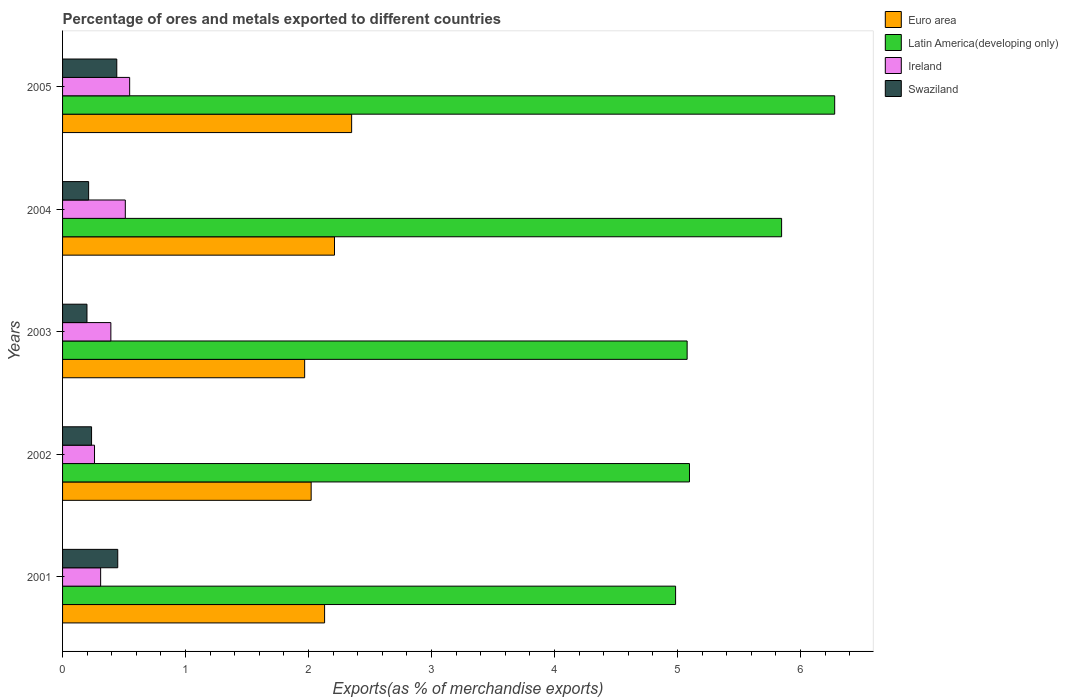How many different coloured bars are there?
Make the answer very short. 4. How many groups of bars are there?
Provide a short and direct response. 5. Are the number of bars per tick equal to the number of legend labels?
Your answer should be compact. Yes. Are the number of bars on each tick of the Y-axis equal?
Your answer should be very brief. Yes. What is the label of the 1st group of bars from the top?
Give a very brief answer. 2005. What is the percentage of exports to different countries in Swaziland in 2005?
Ensure brevity in your answer.  0.44. Across all years, what is the maximum percentage of exports to different countries in Euro area?
Provide a succinct answer. 2.35. Across all years, what is the minimum percentage of exports to different countries in Ireland?
Provide a succinct answer. 0.26. In which year was the percentage of exports to different countries in Latin America(developing only) maximum?
Your answer should be very brief. 2005. What is the total percentage of exports to different countries in Euro area in the graph?
Keep it short and to the point. 10.68. What is the difference between the percentage of exports to different countries in Swaziland in 2001 and that in 2005?
Ensure brevity in your answer.  0.01. What is the difference between the percentage of exports to different countries in Ireland in 2005 and the percentage of exports to different countries in Swaziland in 2003?
Keep it short and to the point. 0.35. What is the average percentage of exports to different countries in Euro area per year?
Give a very brief answer. 2.14. In the year 2001, what is the difference between the percentage of exports to different countries in Ireland and percentage of exports to different countries in Swaziland?
Offer a terse response. -0.14. In how many years, is the percentage of exports to different countries in Ireland greater than 2.6 %?
Offer a very short reply. 0. What is the ratio of the percentage of exports to different countries in Ireland in 2001 to that in 2003?
Your answer should be very brief. 0.79. Is the percentage of exports to different countries in Swaziland in 2004 less than that in 2005?
Offer a terse response. Yes. Is the difference between the percentage of exports to different countries in Ireland in 2001 and 2005 greater than the difference between the percentage of exports to different countries in Swaziland in 2001 and 2005?
Ensure brevity in your answer.  No. What is the difference between the highest and the second highest percentage of exports to different countries in Latin America(developing only)?
Keep it short and to the point. 0.43. What is the difference between the highest and the lowest percentage of exports to different countries in Latin America(developing only)?
Make the answer very short. 1.29. In how many years, is the percentage of exports to different countries in Euro area greater than the average percentage of exports to different countries in Euro area taken over all years?
Your answer should be compact. 2. Is it the case that in every year, the sum of the percentage of exports to different countries in Euro area and percentage of exports to different countries in Ireland is greater than the sum of percentage of exports to different countries in Latin America(developing only) and percentage of exports to different countries in Swaziland?
Offer a terse response. Yes. What does the 2nd bar from the top in 2001 represents?
Offer a terse response. Ireland. What does the 3rd bar from the bottom in 2003 represents?
Your answer should be compact. Ireland. Is it the case that in every year, the sum of the percentage of exports to different countries in Euro area and percentage of exports to different countries in Swaziland is greater than the percentage of exports to different countries in Latin America(developing only)?
Give a very brief answer. No. How many years are there in the graph?
Your response must be concise. 5. Are the values on the major ticks of X-axis written in scientific E-notation?
Ensure brevity in your answer.  No. Does the graph contain any zero values?
Your answer should be compact. No. What is the title of the graph?
Your answer should be compact. Percentage of ores and metals exported to different countries. What is the label or title of the X-axis?
Offer a very short reply. Exports(as % of merchandise exports). What is the label or title of the Y-axis?
Keep it short and to the point. Years. What is the Exports(as % of merchandise exports) of Euro area in 2001?
Your answer should be compact. 2.13. What is the Exports(as % of merchandise exports) of Latin America(developing only) in 2001?
Your answer should be compact. 4.98. What is the Exports(as % of merchandise exports) in Ireland in 2001?
Keep it short and to the point. 0.31. What is the Exports(as % of merchandise exports) in Swaziland in 2001?
Offer a very short reply. 0.45. What is the Exports(as % of merchandise exports) of Euro area in 2002?
Offer a terse response. 2.02. What is the Exports(as % of merchandise exports) of Latin America(developing only) in 2002?
Your response must be concise. 5.1. What is the Exports(as % of merchandise exports) in Ireland in 2002?
Ensure brevity in your answer.  0.26. What is the Exports(as % of merchandise exports) of Swaziland in 2002?
Ensure brevity in your answer.  0.24. What is the Exports(as % of merchandise exports) of Euro area in 2003?
Provide a succinct answer. 1.97. What is the Exports(as % of merchandise exports) of Latin America(developing only) in 2003?
Give a very brief answer. 5.08. What is the Exports(as % of merchandise exports) in Ireland in 2003?
Provide a succinct answer. 0.39. What is the Exports(as % of merchandise exports) in Swaziland in 2003?
Your answer should be compact. 0.2. What is the Exports(as % of merchandise exports) in Euro area in 2004?
Make the answer very short. 2.21. What is the Exports(as % of merchandise exports) in Latin America(developing only) in 2004?
Make the answer very short. 5.85. What is the Exports(as % of merchandise exports) in Ireland in 2004?
Provide a succinct answer. 0.51. What is the Exports(as % of merchandise exports) of Swaziland in 2004?
Provide a succinct answer. 0.21. What is the Exports(as % of merchandise exports) in Euro area in 2005?
Provide a short and direct response. 2.35. What is the Exports(as % of merchandise exports) in Latin America(developing only) in 2005?
Ensure brevity in your answer.  6.28. What is the Exports(as % of merchandise exports) in Ireland in 2005?
Ensure brevity in your answer.  0.55. What is the Exports(as % of merchandise exports) of Swaziland in 2005?
Provide a short and direct response. 0.44. Across all years, what is the maximum Exports(as % of merchandise exports) of Euro area?
Provide a short and direct response. 2.35. Across all years, what is the maximum Exports(as % of merchandise exports) in Latin America(developing only)?
Make the answer very short. 6.28. Across all years, what is the maximum Exports(as % of merchandise exports) in Ireland?
Offer a terse response. 0.55. Across all years, what is the maximum Exports(as % of merchandise exports) of Swaziland?
Offer a terse response. 0.45. Across all years, what is the minimum Exports(as % of merchandise exports) in Euro area?
Your answer should be compact. 1.97. Across all years, what is the minimum Exports(as % of merchandise exports) of Latin America(developing only)?
Make the answer very short. 4.98. Across all years, what is the minimum Exports(as % of merchandise exports) of Ireland?
Ensure brevity in your answer.  0.26. Across all years, what is the minimum Exports(as % of merchandise exports) of Swaziland?
Your answer should be very brief. 0.2. What is the total Exports(as % of merchandise exports) of Euro area in the graph?
Ensure brevity in your answer.  10.68. What is the total Exports(as % of merchandise exports) of Latin America(developing only) in the graph?
Your answer should be compact. 27.29. What is the total Exports(as % of merchandise exports) in Ireland in the graph?
Your answer should be very brief. 2.02. What is the total Exports(as % of merchandise exports) in Swaziland in the graph?
Offer a terse response. 1.54. What is the difference between the Exports(as % of merchandise exports) of Euro area in 2001 and that in 2002?
Ensure brevity in your answer.  0.11. What is the difference between the Exports(as % of merchandise exports) of Latin America(developing only) in 2001 and that in 2002?
Your response must be concise. -0.11. What is the difference between the Exports(as % of merchandise exports) of Ireland in 2001 and that in 2002?
Offer a terse response. 0.05. What is the difference between the Exports(as % of merchandise exports) in Swaziland in 2001 and that in 2002?
Make the answer very short. 0.21. What is the difference between the Exports(as % of merchandise exports) of Euro area in 2001 and that in 2003?
Keep it short and to the point. 0.16. What is the difference between the Exports(as % of merchandise exports) of Latin America(developing only) in 2001 and that in 2003?
Provide a succinct answer. -0.09. What is the difference between the Exports(as % of merchandise exports) of Ireland in 2001 and that in 2003?
Ensure brevity in your answer.  -0.08. What is the difference between the Exports(as % of merchandise exports) in Swaziland in 2001 and that in 2003?
Make the answer very short. 0.25. What is the difference between the Exports(as % of merchandise exports) in Euro area in 2001 and that in 2004?
Your response must be concise. -0.08. What is the difference between the Exports(as % of merchandise exports) in Latin America(developing only) in 2001 and that in 2004?
Your response must be concise. -0.86. What is the difference between the Exports(as % of merchandise exports) in Ireland in 2001 and that in 2004?
Offer a very short reply. -0.2. What is the difference between the Exports(as % of merchandise exports) of Swaziland in 2001 and that in 2004?
Give a very brief answer. 0.24. What is the difference between the Exports(as % of merchandise exports) in Euro area in 2001 and that in 2005?
Provide a short and direct response. -0.22. What is the difference between the Exports(as % of merchandise exports) in Latin America(developing only) in 2001 and that in 2005?
Ensure brevity in your answer.  -1.29. What is the difference between the Exports(as % of merchandise exports) of Ireland in 2001 and that in 2005?
Your answer should be compact. -0.24. What is the difference between the Exports(as % of merchandise exports) in Swaziland in 2001 and that in 2005?
Your response must be concise. 0.01. What is the difference between the Exports(as % of merchandise exports) in Euro area in 2002 and that in 2003?
Provide a succinct answer. 0.05. What is the difference between the Exports(as % of merchandise exports) of Latin America(developing only) in 2002 and that in 2003?
Your answer should be compact. 0.02. What is the difference between the Exports(as % of merchandise exports) in Ireland in 2002 and that in 2003?
Provide a succinct answer. -0.13. What is the difference between the Exports(as % of merchandise exports) of Swaziland in 2002 and that in 2003?
Offer a terse response. 0.04. What is the difference between the Exports(as % of merchandise exports) of Euro area in 2002 and that in 2004?
Your answer should be very brief. -0.19. What is the difference between the Exports(as % of merchandise exports) of Latin America(developing only) in 2002 and that in 2004?
Ensure brevity in your answer.  -0.75. What is the difference between the Exports(as % of merchandise exports) of Ireland in 2002 and that in 2004?
Your answer should be very brief. -0.25. What is the difference between the Exports(as % of merchandise exports) in Swaziland in 2002 and that in 2004?
Ensure brevity in your answer.  0.02. What is the difference between the Exports(as % of merchandise exports) in Euro area in 2002 and that in 2005?
Your answer should be very brief. -0.33. What is the difference between the Exports(as % of merchandise exports) of Latin America(developing only) in 2002 and that in 2005?
Your answer should be compact. -1.18. What is the difference between the Exports(as % of merchandise exports) in Ireland in 2002 and that in 2005?
Your response must be concise. -0.29. What is the difference between the Exports(as % of merchandise exports) in Swaziland in 2002 and that in 2005?
Offer a very short reply. -0.21. What is the difference between the Exports(as % of merchandise exports) in Euro area in 2003 and that in 2004?
Provide a succinct answer. -0.24. What is the difference between the Exports(as % of merchandise exports) in Latin America(developing only) in 2003 and that in 2004?
Give a very brief answer. -0.77. What is the difference between the Exports(as % of merchandise exports) in Ireland in 2003 and that in 2004?
Give a very brief answer. -0.12. What is the difference between the Exports(as % of merchandise exports) in Swaziland in 2003 and that in 2004?
Offer a terse response. -0.01. What is the difference between the Exports(as % of merchandise exports) in Euro area in 2003 and that in 2005?
Your answer should be very brief. -0.38. What is the difference between the Exports(as % of merchandise exports) in Latin America(developing only) in 2003 and that in 2005?
Provide a short and direct response. -1.2. What is the difference between the Exports(as % of merchandise exports) of Ireland in 2003 and that in 2005?
Your answer should be compact. -0.15. What is the difference between the Exports(as % of merchandise exports) of Swaziland in 2003 and that in 2005?
Give a very brief answer. -0.24. What is the difference between the Exports(as % of merchandise exports) of Euro area in 2004 and that in 2005?
Your answer should be very brief. -0.14. What is the difference between the Exports(as % of merchandise exports) in Latin America(developing only) in 2004 and that in 2005?
Ensure brevity in your answer.  -0.43. What is the difference between the Exports(as % of merchandise exports) in Ireland in 2004 and that in 2005?
Ensure brevity in your answer.  -0.04. What is the difference between the Exports(as % of merchandise exports) of Swaziland in 2004 and that in 2005?
Your answer should be compact. -0.23. What is the difference between the Exports(as % of merchandise exports) in Euro area in 2001 and the Exports(as % of merchandise exports) in Latin America(developing only) in 2002?
Keep it short and to the point. -2.97. What is the difference between the Exports(as % of merchandise exports) of Euro area in 2001 and the Exports(as % of merchandise exports) of Ireland in 2002?
Your response must be concise. 1.87. What is the difference between the Exports(as % of merchandise exports) of Euro area in 2001 and the Exports(as % of merchandise exports) of Swaziland in 2002?
Keep it short and to the point. 1.89. What is the difference between the Exports(as % of merchandise exports) in Latin America(developing only) in 2001 and the Exports(as % of merchandise exports) in Ireland in 2002?
Provide a succinct answer. 4.72. What is the difference between the Exports(as % of merchandise exports) in Latin America(developing only) in 2001 and the Exports(as % of merchandise exports) in Swaziland in 2002?
Your answer should be compact. 4.75. What is the difference between the Exports(as % of merchandise exports) of Ireland in 2001 and the Exports(as % of merchandise exports) of Swaziland in 2002?
Ensure brevity in your answer.  0.07. What is the difference between the Exports(as % of merchandise exports) in Euro area in 2001 and the Exports(as % of merchandise exports) in Latin America(developing only) in 2003?
Provide a short and direct response. -2.95. What is the difference between the Exports(as % of merchandise exports) of Euro area in 2001 and the Exports(as % of merchandise exports) of Ireland in 2003?
Give a very brief answer. 1.74. What is the difference between the Exports(as % of merchandise exports) in Euro area in 2001 and the Exports(as % of merchandise exports) in Swaziland in 2003?
Ensure brevity in your answer.  1.93. What is the difference between the Exports(as % of merchandise exports) in Latin America(developing only) in 2001 and the Exports(as % of merchandise exports) in Ireland in 2003?
Provide a succinct answer. 4.59. What is the difference between the Exports(as % of merchandise exports) in Latin America(developing only) in 2001 and the Exports(as % of merchandise exports) in Swaziland in 2003?
Provide a short and direct response. 4.79. What is the difference between the Exports(as % of merchandise exports) in Ireland in 2001 and the Exports(as % of merchandise exports) in Swaziland in 2003?
Your answer should be compact. 0.11. What is the difference between the Exports(as % of merchandise exports) of Euro area in 2001 and the Exports(as % of merchandise exports) of Latin America(developing only) in 2004?
Your answer should be very brief. -3.72. What is the difference between the Exports(as % of merchandise exports) of Euro area in 2001 and the Exports(as % of merchandise exports) of Ireland in 2004?
Provide a short and direct response. 1.62. What is the difference between the Exports(as % of merchandise exports) of Euro area in 2001 and the Exports(as % of merchandise exports) of Swaziland in 2004?
Your answer should be very brief. 1.92. What is the difference between the Exports(as % of merchandise exports) in Latin America(developing only) in 2001 and the Exports(as % of merchandise exports) in Ireland in 2004?
Offer a terse response. 4.47. What is the difference between the Exports(as % of merchandise exports) in Latin America(developing only) in 2001 and the Exports(as % of merchandise exports) in Swaziland in 2004?
Offer a terse response. 4.77. What is the difference between the Exports(as % of merchandise exports) of Ireland in 2001 and the Exports(as % of merchandise exports) of Swaziland in 2004?
Your response must be concise. 0.1. What is the difference between the Exports(as % of merchandise exports) in Euro area in 2001 and the Exports(as % of merchandise exports) in Latin America(developing only) in 2005?
Ensure brevity in your answer.  -4.15. What is the difference between the Exports(as % of merchandise exports) of Euro area in 2001 and the Exports(as % of merchandise exports) of Ireland in 2005?
Ensure brevity in your answer.  1.59. What is the difference between the Exports(as % of merchandise exports) of Euro area in 2001 and the Exports(as % of merchandise exports) of Swaziland in 2005?
Give a very brief answer. 1.69. What is the difference between the Exports(as % of merchandise exports) of Latin America(developing only) in 2001 and the Exports(as % of merchandise exports) of Ireland in 2005?
Offer a very short reply. 4.44. What is the difference between the Exports(as % of merchandise exports) of Latin America(developing only) in 2001 and the Exports(as % of merchandise exports) of Swaziland in 2005?
Provide a succinct answer. 4.54. What is the difference between the Exports(as % of merchandise exports) of Ireland in 2001 and the Exports(as % of merchandise exports) of Swaziland in 2005?
Provide a succinct answer. -0.13. What is the difference between the Exports(as % of merchandise exports) in Euro area in 2002 and the Exports(as % of merchandise exports) in Latin America(developing only) in 2003?
Keep it short and to the point. -3.06. What is the difference between the Exports(as % of merchandise exports) of Euro area in 2002 and the Exports(as % of merchandise exports) of Ireland in 2003?
Ensure brevity in your answer.  1.63. What is the difference between the Exports(as % of merchandise exports) of Euro area in 2002 and the Exports(as % of merchandise exports) of Swaziland in 2003?
Your answer should be compact. 1.82. What is the difference between the Exports(as % of merchandise exports) in Latin America(developing only) in 2002 and the Exports(as % of merchandise exports) in Ireland in 2003?
Keep it short and to the point. 4.71. What is the difference between the Exports(as % of merchandise exports) of Latin America(developing only) in 2002 and the Exports(as % of merchandise exports) of Swaziland in 2003?
Ensure brevity in your answer.  4.9. What is the difference between the Exports(as % of merchandise exports) in Ireland in 2002 and the Exports(as % of merchandise exports) in Swaziland in 2003?
Your answer should be compact. 0.06. What is the difference between the Exports(as % of merchandise exports) in Euro area in 2002 and the Exports(as % of merchandise exports) in Latin America(developing only) in 2004?
Offer a very short reply. -3.83. What is the difference between the Exports(as % of merchandise exports) in Euro area in 2002 and the Exports(as % of merchandise exports) in Ireland in 2004?
Keep it short and to the point. 1.51. What is the difference between the Exports(as % of merchandise exports) of Euro area in 2002 and the Exports(as % of merchandise exports) of Swaziland in 2004?
Your response must be concise. 1.81. What is the difference between the Exports(as % of merchandise exports) of Latin America(developing only) in 2002 and the Exports(as % of merchandise exports) of Ireland in 2004?
Your answer should be very brief. 4.59. What is the difference between the Exports(as % of merchandise exports) in Latin America(developing only) in 2002 and the Exports(as % of merchandise exports) in Swaziland in 2004?
Your answer should be compact. 4.89. What is the difference between the Exports(as % of merchandise exports) of Ireland in 2002 and the Exports(as % of merchandise exports) of Swaziland in 2004?
Keep it short and to the point. 0.05. What is the difference between the Exports(as % of merchandise exports) of Euro area in 2002 and the Exports(as % of merchandise exports) of Latin America(developing only) in 2005?
Offer a terse response. -4.26. What is the difference between the Exports(as % of merchandise exports) of Euro area in 2002 and the Exports(as % of merchandise exports) of Ireland in 2005?
Provide a succinct answer. 1.48. What is the difference between the Exports(as % of merchandise exports) of Euro area in 2002 and the Exports(as % of merchandise exports) of Swaziland in 2005?
Give a very brief answer. 1.58. What is the difference between the Exports(as % of merchandise exports) of Latin America(developing only) in 2002 and the Exports(as % of merchandise exports) of Ireland in 2005?
Make the answer very short. 4.55. What is the difference between the Exports(as % of merchandise exports) of Latin America(developing only) in 2002 and the Exports(as % of merchandise exports) of Swaziland in 2005?
Ensure brevity in your answer.  4.66. What is the difference between the Exports(as % of merchandise exports) in Ireland in 2002 and the Exports(as % of merchandise exports) in Swaziland in 2005?
Your answer should be very brief. -0.18. What is the difference between the Exports(as % of merchandise exports) in Euro area in 2003 and the Exports(as % of merchandise exports) in Latin America(developing only) in 2004?
Provide a short and direct response. -3.88. What is the difference between the Exports(as % of merchandise exports) in Euro area in 2003 and the Exports(as % of merchandise exports) in Ireland in 2004?
Ensure brevity in your answer.  1.46. What is the difference between the Exports(as % of merchandise exports) in Euro area in 2003 and the Exports(as % of merchandise exports) in Swaziland in 2004?
Offer a very short reply. 1.76. What is the difference between the Exports(as % of merchandise exports) in Latin America(developing only) in 2003 and the Exports(as % of merchandise exports) in Ireland in 2004?
Offer a very short reply. 4.57. What is the difference between the Exports(as % of merchandise exports) of Latin America(developing only) in 2003 and the Exports(as % of merchandise exports) of Swaziland in 2004?
Your answer should be compact. 4.87. What is the difference between the Exports(as % of merchandise exports) of Ireland in 2003 and the Exports(as % of merchandise exports) of Swaziland in 2004?
Your answer should be compact. 0.18. What is the difference between the Exports(as % of merchandise exports) of Euro area in 2003 and the Exports(as % of merchandise exports) of Latin America(developing only) in 2005?
Your answer should be very brief. -4.31. What is the difference between the Exports(as % of merchandise exports) of Euro area in 2003 and the Exports(as % of merchandise exports) of Ireland in 2005?
Offer a very short reply. 1.42. What is the difference between the Exports(as % of merchandise exports) in Euro area in 2003 and the Exports(as % of merchandise exports) in Swaziland in 2005?
Your answer should be compact. 1.53. What is the difference between the Exports(as % of merchandise exports) in Latin America(developing only) in 2003 and the Exports(as % of merchandise exports) in Ireland in 2005?
Keep it short and to the point. 4.53. What is the difference between the Exports(as % of merchandise exports) of Latin America(developing only) in 2003 and the Exports(as % of merchandise exports) of Swaziland in 2005?
Your response must be concise. 4.64. What is the difference between the Exports(as % of merchandise exports) in Ireland in 2003 and the Exports(as % of merchandise exports) in Swaziland in 2005?
Keep it short and to the point. -0.05. What is the difference between the Exports(as % of merchandise exports) in Euro area in 2004 and the Exports(as % of merchandise exports) in Latin America(developing only) in 2005?
Offer a terse response. -4.07. What is the difference between the Exports(as % of merchandise exports) of Euro area in 2004 and the Exports(as % of merchandise exports) of Ireland in 2005?
Your response must be concise. 1.67. What is the difference between the Exports(as % of merchandise exports) of Euro area in 2004 and the Exports(as % of merchandise exports) of Swaziland in 2005?
Keep it short and to the point. 1.77. What is the difference between the Exports(as % of merchandise exports) of Latin America(developing only) in 2004 and the Exports(as % of merchandise exports) of Ireland in 2005?
Your response must be concise. 5.3. What is the difference between the Exports(as % of merchandise exports) of Latin America(developing only) in 2004 and the Exports(as % of merchandise exports) of Swaziland in 2005?
Your answer should be compact. 5.41. What is the difference between the Exports(as % of merchandise exports) of Ireland in 2004 and the Exports(as % of merchandise exports) of Swaziland in 2005?
Your response must be concise. 0.07. What is the average Exports(as % of merchandise exports) in Euro area per year?
Ensure brevity in your answer.  2.14. What is the average Exports(as % of merchandise exports) of Latin America(developing only) per year?
Ensure brevity in your answer.  5.46. What is the average Exports(as % of merchandise exports) of Ireland per year?
Make the answer very short. 0.4. What is the average Exports(as % of merchandise exports) in Swaziland per year?
Give a very brief answer. 0.31. In the year 2001, what is the difference between the Exports(as % of merchandise exports) of Euro area and Exports(as % of merchandise exports) of Latin America(developing only)?
Keep it short and to the point. -2.85. In the year 2001, what is the difference between the Exports(as % of merchandise exports) in Euro area and Exports(as % of merchandise exports) in Ireland?
Make the answer very short. 1.82. In the year 2001, what is the difference between the Exports(as % of merchandise exports) of Euro area and Exports(as % of merchandise exports) of Swaziland?
Keep it short and to the point. 1.68. In the year 2001, what is the difference between the Exports(as % of merchandise exports) in Latin America(developing only) and Exports(as % of merchandise exports) in Ireland?
Offer a terse response. 4.68. In the year 2001, what is the difference between the Exports(as % of merchandise exports) of Latin America(developing only) and Exports(as % of merchandise exports) of Swaziland?
Your response must be concise. 4.54. In the year 2001, what is the difference between the Exports(as % of merchandise exports) of Ireland and Exports(as % of merchandise exports) of Swaziland?
Offer a terse response. -0.14. In the year 2002, what is the difference between the Exports(as % of merchandise exports) of Euro area and Exports(as % of merchandise exports) of Latin America(developing only)?
Offer a very short reply. -3.08. In the year 2002, what is the difference between the Exports(as % of merchandise exports) in Euro area and Exports(as % of merchandise exports) in Ireland?
Your answer should be compact. 1.76. In the year 2002, what is the difference between the Exports(as % of merchandise exports) of Euro area and Exports(as % of merchandise exports) of Swaziland?
Offer a terse response. 1.79. In the year 2002, what is the difference between the Exports(as % of merchandise exports) of Latin America(developing only) and Exports(as % of merchandise exports) of Ireland?
Make the answer very short. 4.84. In the year 2002, what is the difference between the Exports(as % of merchandise exports) in Latin America(developing only) and Exports(as % of merchandise exports) in Swaziland?
Make the answer very short. 4.86. In the year 2002, what is the difference between the Exports(as % of merchandise exports) of Ireland and Exports(as % of merchandise exports) of Swaziland?
Your response must be concise. 0.02. In the year 2003, what is the difference between the Exports(as % of merchandise exports) in Euro area and Exports(as % of merchandise exports) in Latin America(developing only)?
Keep it short and to the point. -3.11. In the year 2003, what is the difference between the Exports(as % of merchandise exports) of Euro area and Exports(as % of merchandise exports) of Ireland?
Make the answer very short. 1.58. In the year 2003, what is the difference between the Exports(as % of merchandise exports) in Euro area and Exports(as % of merchandise exports) in Swaziland?
Make the answer very short. 1.77. In the year 2003, what is the difference between the Exports(as % of merchandise exports) of Latin America(developing only) and Exports(as % of merchandise exports) of Ireland?
Ensure brevity in your answer.  4.69. In the year 2003, what is the difference between the Exports(as % of merchandise exports) in Latin America(developing only) and Exports(as % of merchandise exports) in Swaziland?
Your response must be concise. 4.88. In the year 2003, what is the difference between the Exports(as % of merchandise exports) in Ireland and Exports(as % of merchandise exports) in Swaziland?
Offer a very short reply. 0.19. In the year 2004, what is the difference between the Exports(as % of merchandise exports) in Euro area and Exports(as % of merchandise exports) in Latin America(developing only)?
Your answer should be compact. -3.64. In the year 2004, what is the difference between the Exports(as % of merchandise exports) of Euro area and Exports(as % of merchandise exports) of Ireland?
Provide a short and direct response. 1.7. In the year 2004, what is the difference between the Exports(as % of merchandise exports) of Euro area and Exports(as % of merchandise exports) of Swaziland?
Your response must be concise. 2. In the year 2004, what is the difference between the Exports(as % of merchandise exports) in Latin America(developing only) and Exports(as % of merchandise exports) in Ireland?
Keep it short and to the point. 5.34. In the year 2004, what is the difference between the Exports(as % of merchandise exports) in Latin America(developing only) and Exports(as % of merchandise exports) in Swaziland?
Offer a very short reply. 5.63. In the year 2004, what is the difference between the Exports(as % of merchandise exports) in Ireland and Exports(as % of merchandise exports) in Swaziland?
Provide a short and direct response. 0.3. In the year 2005, what is the difference between the Exports(as % of merchandise exports) of Euro area and Exports(as % of merchandise exports) of Latin America(developing only)?
Provide a short and direct response. -3.93. In the year 2005, what is the difference between the Exports(as % of merchandise exports) of Euro area and Exports(as % of merchandise exports) of Ireland?
Keep it short and to the point. 1.8. In the year 2005, what is the difference between the Exports(as % of merchandise exports) in Euro area and Exports(as % of merchandise exports) in Swaziland?
Your answer should be compact. 1.91. In the year 2005, what is the difference between the Exports(as % of merchandise exports) in Latin America(developing only) and Exports(as % of merchandise exports) in Ireland?
Keep it short and to the point. 5.73. In the year 2005, what is the difference between the Exports(as % of merchandise exports) of Latin America(developing only) and Exports(as % of merchandise exports) of Swaziland?
Make the answer very short. 5.84. In the year 2005, what is the difference between the Exports(as % of merchandise exports) in Ireland and Exports(as % of merchandise exports) in Swaziland?
Make the answer very short. 0.1. What is the ratio of the Exports(as % of merchandise exports) in Euro area in 2001 to that in 2002?
Ensure brevity in your answer.  1.05. What is the ratio of the Exports(as % of merchandise exports) of Latin America(developing only) in 2001 to that in 2002?
Ensure brevity in your answer.  0.98. What is the ratio of the Exports(as % of merchandise exports) in Ireland in 2001 to that in 2002?
Provide a short and direct response. 1.19. What is the ratio of the Exports(as % of merchandise exports) of Swaziland in 2001 to that in 2002?
Give a very brief answer. 1.9. What is the ratio of the Exports(as % of merchandise exports) in Euro area in 2001 to that in 2003?
Provide a short and direct response. 1.08. What is the ratio of the Exports(as % of merchandise exports) of Latin America(developing only) in 2001 to that in 2003?
Give a very brief answer. 0.98. What is the ratio of the Exports(as % of merchandise exports) in Ireland in 2001 to that in 2003?
Your answer should be very brief. 0.79. What is the ratio of the Exports(as % of merchandise exports) of Swaziland in 2001 to that in 2003?
Make the answer very short. 2.26. What is the ratio of the Exports(as % of merchandise exports) of Euro area in 2001 to that in 2004?
Make the answer very short. 0.96. What is the ratio of the Exports(as % of merchandise exports) in Latin America(developing only) in 2001 to that in 2004?
Your response must be concise. 0.85. What is the ratio of the Exports(as % of merchandise exports) in Ireland in 2001 to that in 2004?
Ensure brevity in your answer.  0.61. What is the ratio of the Exports(as % of merchandise exports) in Swaziland in 2001 to that in 2004?
Give a very brief answer. 2.12. What is the ratio of the Exports(as % of merchandise exports) in Euro area in 2001 to that in 2005?
Offer a very short reply. 0.91. What is the ratio of the Exports(as % of merchandise exports) of Latin America(developing only) in 2001 to that in 2005?
Your answer should be compact. 0.79. What is the ratio of the Exports(as % of merchandise exports) in Ireland in 2001 to that in 2005?
Provide a short and direct response. 0.57. What is the ratio of the Exports(as % of merchandise exports) in Swaziland in 2001 to that in 2005?
Offer a very short reply. 1.02. What is the ratio of the Exports(as % of merchandise exports) of Euro area in 2002 to that in 2003?
Ensure brevity in your answer.  1.03. What is the ratio of the Exports(as % of merchandise exports) of Ireland in 2002 to that in 2003?
Your response must be concise. 0.66. What is the ratio of the Exports(as % of merchandise exports) in Swaziland in 2002 to that in 2003?
Ensure brevity in your answer.  1.19. What is the ratio of the Exports(as % of merchandise exports) of Euro area in 2002 to that in 2004?
Give a very brief answer. 0.91. What is the ratio of the Exports(as % of merchandise exports) of Latin America(developing only) in 2002 to that in 2004?
Your response must be concise. 0.87. What is the ratio of the Exports(as % of merchandise exports) in Ireland in 2002 to that in 2004?
Your answer should be very brief. 0.51. What is the ratio of the Exports(as % of merchandise exports) of Swaziland in 2002 to that in 2004?
Ensure brevity in your answer.  1.11. What is the ratio of the Exports(as % of merchandise exports) in Euro area in 2002 to that in 2005?
Ensure brevity in your answer.  0.86. What is the ratio of the Exports(as % of merchandise exports) of Latin America(developing only) in 2002 to that in 2005?
Give a very brief answer. 0.81. What is the ratio of the Exports(as % of merchandise exports) of Ireland in 2002 to that in 2005?
Give a very brief answer. 0.48. What is the ratio of the Exports(as % of merchandise exports) in Swaziland in 2002 to that in 2005?
Your answer should be very brief. 0.53. What is the ratio of the Exports(as % of merchandise exports) in Euro area in 2003 to that in 2004?
Ensure brevity in your answer.  0.89. What is the ratio of the Exports(as % of merchandise exports) of Latin America(developing only) in 2003 to that in 2004?
Provide a succinct answer. 0.87. What is the ratio of the Exports(as % of merchandise exports) of Ireland in 2003 to that in 2004?
Keep it short and to the point. 0.77. What is the ratio of the Exports(as % of merchandise exports) in Swaziland in 2003 to that in 2004?
Provide a short and direct response. 0.94. What is the ratio of the Exports(as % of merchandise exports) in Euro area in 2003 to that in 2005?
Offer a very short reply. 0.84. What is the ratio of the Exports(as % of merchandise exports) of Latin America(developing only) in 2003 to that in 2005?
Provide a short and direct response. 0.81. What is the ratio of the Exports(as % of merchandise exports) in Ireland in 2003 to that in 2005?
Provide a short and direct response. 0.72. What is the ratio of the Exports(as % of merchandise exports) in Swaziland in 2003 to that in 2005?
Your answer should be very brief. 0.45. What is the ratio of the Exports(as % of merchandise exports) in Euro area in 2004 to that in 2005?
Your response must be concise. 0.94. What is the ratio of the Exports(as % of merchandise exports) of Latin America(developing only) in 2004 to that in 2005?
Offer a terse response. 0.93. What is the ratio of the Exports(as % of merchandise exports) of Ireland in 2004 to that in 2005?
Keep it short and to the point. 0.94. What is the ratio of the Exports(as % of merchandise exports) of Swaziland in 2004 to that in 2005?
Provide a succinct answer. 0.48. What is the difference between the highest and the second highest Exports(as % of merchandise exports) of Euro area?
Provide a succinct answer. 0.14. What is the difference between the highest and the second highest Exports(as % of merchandise exports) of Latin America(developing only)?
Provide a succinct answer. 0.43. What is the difference between the highest and the second highest Exports(as % of merchandise exports) in Ireland?
Keep it short and to the point. 0.04. What is the difference between the highest and the second highest Exports(as % of merchandise exports) of Swaziland?
Offer a very short reply. 0.01. What is the difference between the highest and the lowest Exports(as % of merchandise exports) in Euro area?
Provide a short and direct response. 0.38. What is the difference between the highest and the lowest Exports(as % of merchandise exports) in Latin America(developing only)?
Provide a short and direct response. 1.29. What is the difference between the highest and the lowest Exports(as % of merchandise exports) in Ireland?
Your answer should be very brief. 0.29. What is the difference between the highest and the lowest Exports(as % of merchandise exports) in Swaziland?
Provide a succinct answer. 0.25. 